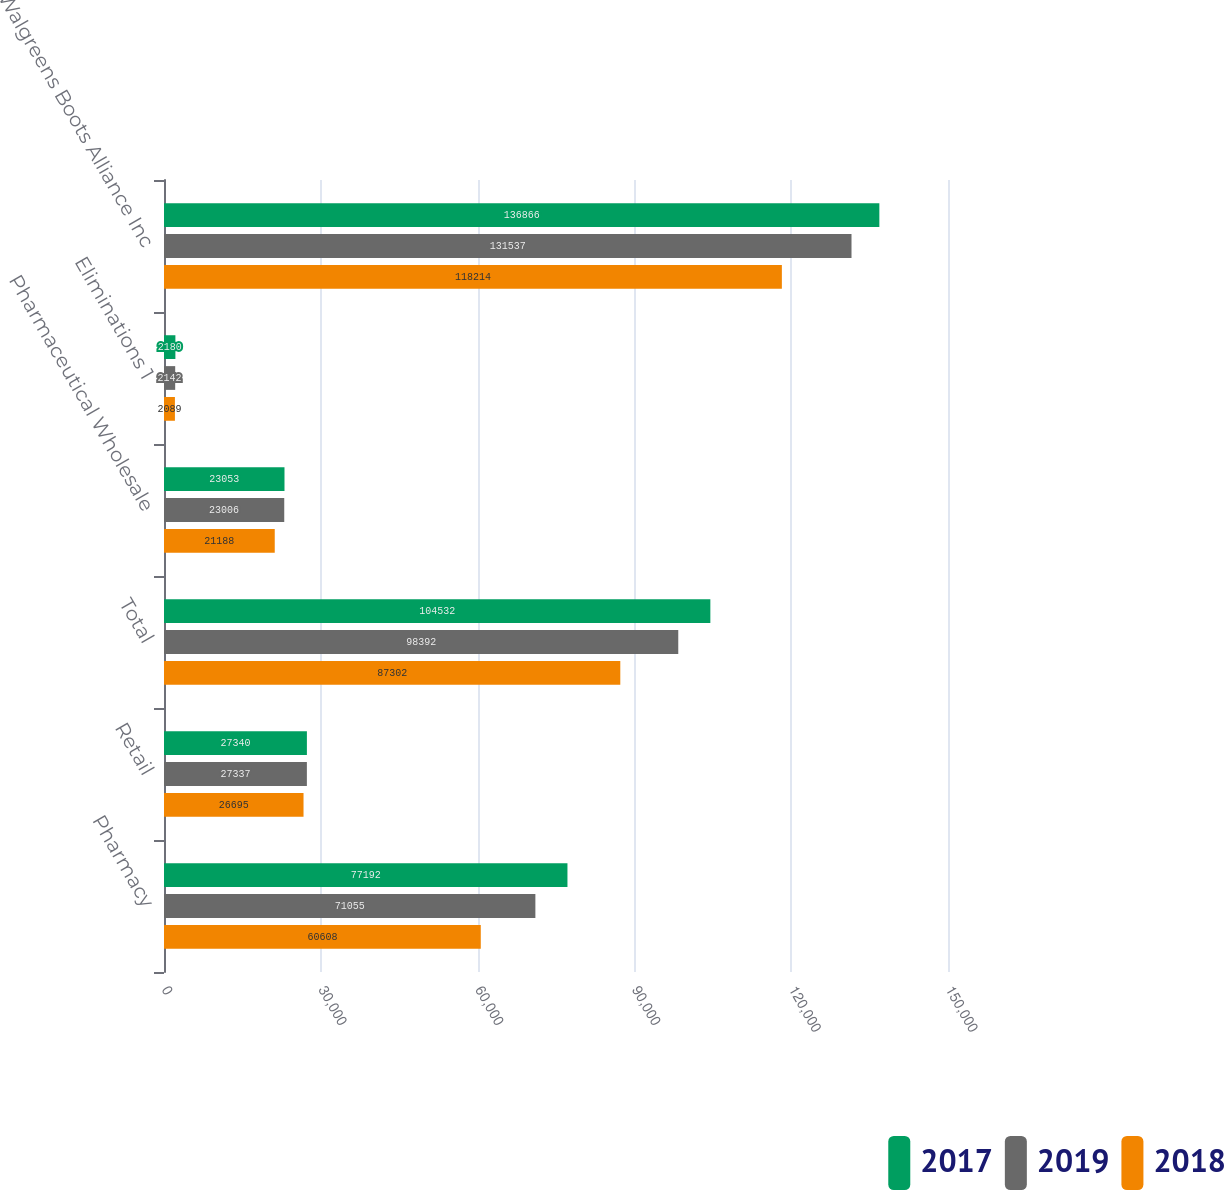Convert chart. <chart><loc_0><loc_0><loc_500><loc_500><stacked_bar_chart><ecel><fcel>Pharmacy<fcel>Retail<fcel>Total<fcel>Pharmaceutical Wholesale<fcel>Eliminations 1<fcel>Walgreens Boots Alliance Inc<nl><fcel>2017<fcel>77192<fcel>27340<fcel>104532<fcel>23053<fcel>2180<fcel>136866<nl><fcel>2019<fcel>71055<fcel>27337<fcel>98392<fcel>23006<fcel>2142<fcel>131537<nl><fcel>2018<fcel>60608<fcel>26695<fcel>87302<fcel>21188<fcel>2089<fcel>118214<nl></chart> 